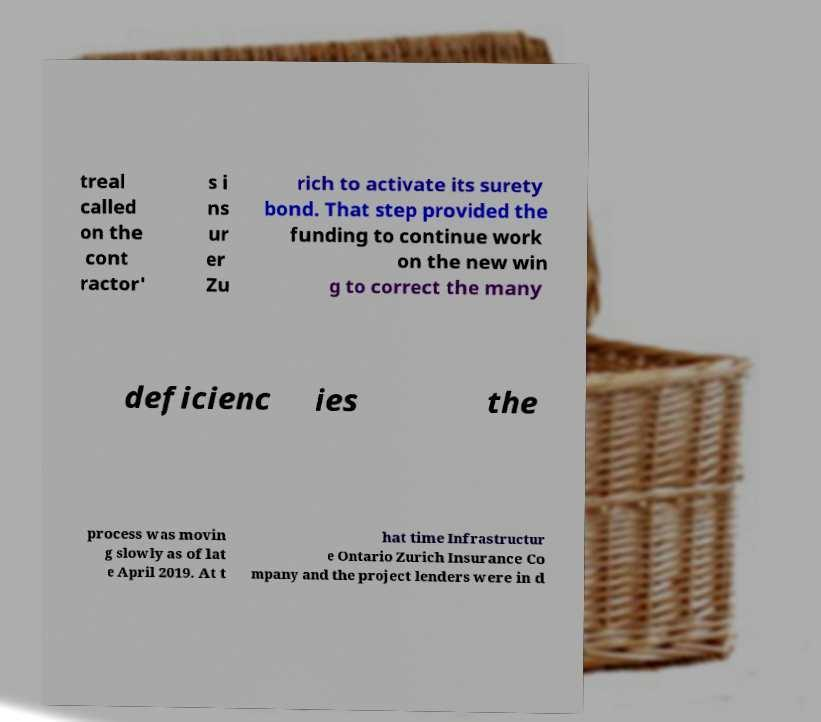Please identify and transcribe the text found in this image. treal called on the cont ractor' s i ns ur er Zu rich to activate its surety bond. That step provided the funding to continue work on the new win g to correct the many deficienc ies the process was movin g slowly as of lat e April 2019. At t hat time Infrastructur e Ontario Zurich Insurance Co mpany and the project lenders were in d 